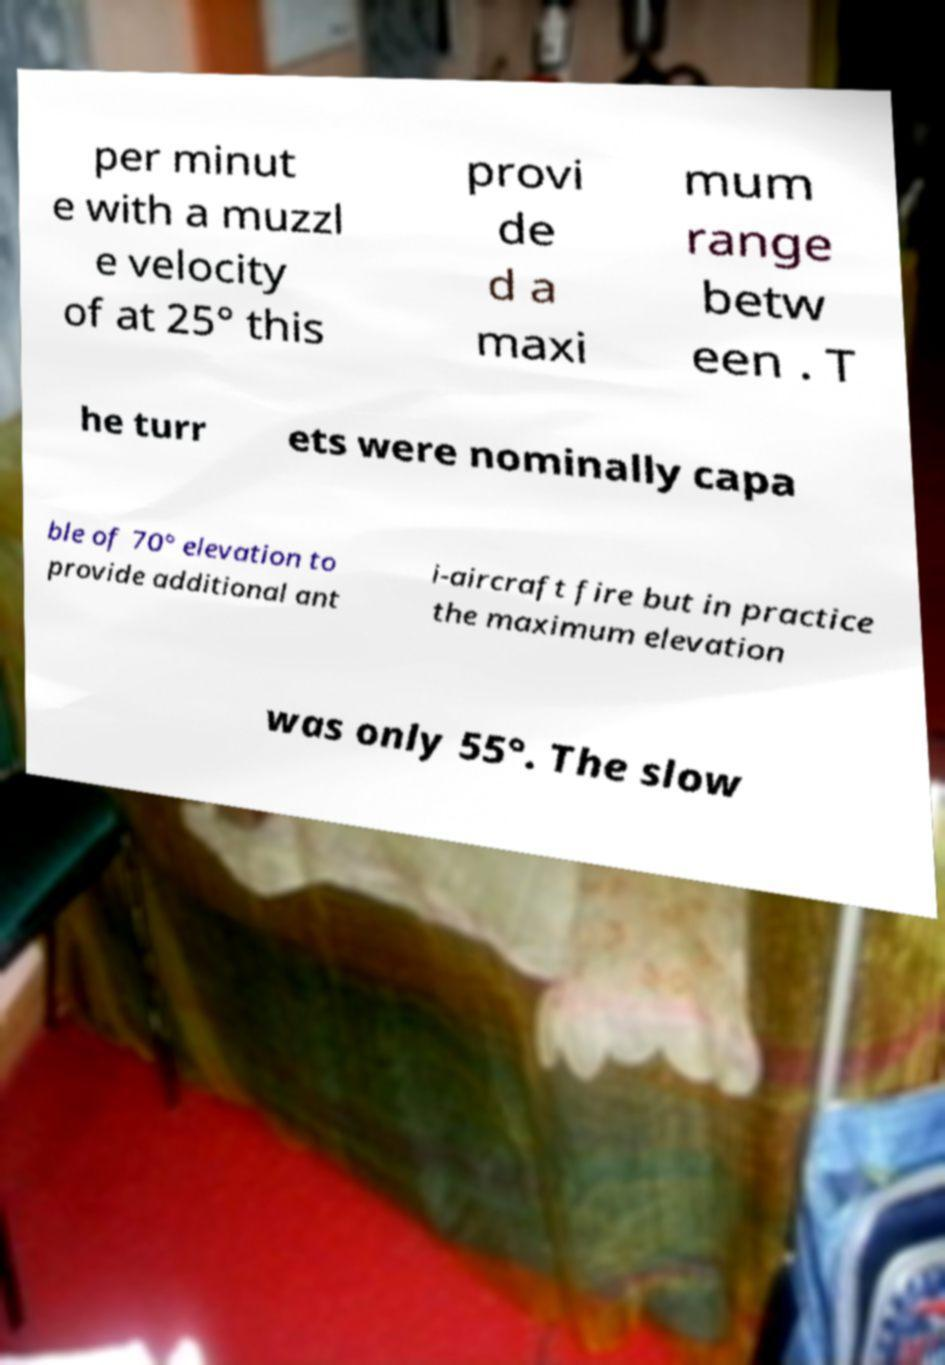There's text embedded in this image that I need extracted. Can you transcribe it verbatim? per minut e with a muzzl e velocity of at 25° this provi de d a maxi mum range betw een . T he turr ets were nominally capa ble of 70° elevation to provide additional ant i-aircraft fire but in practice the maximum elevation was only 55°. The slow 